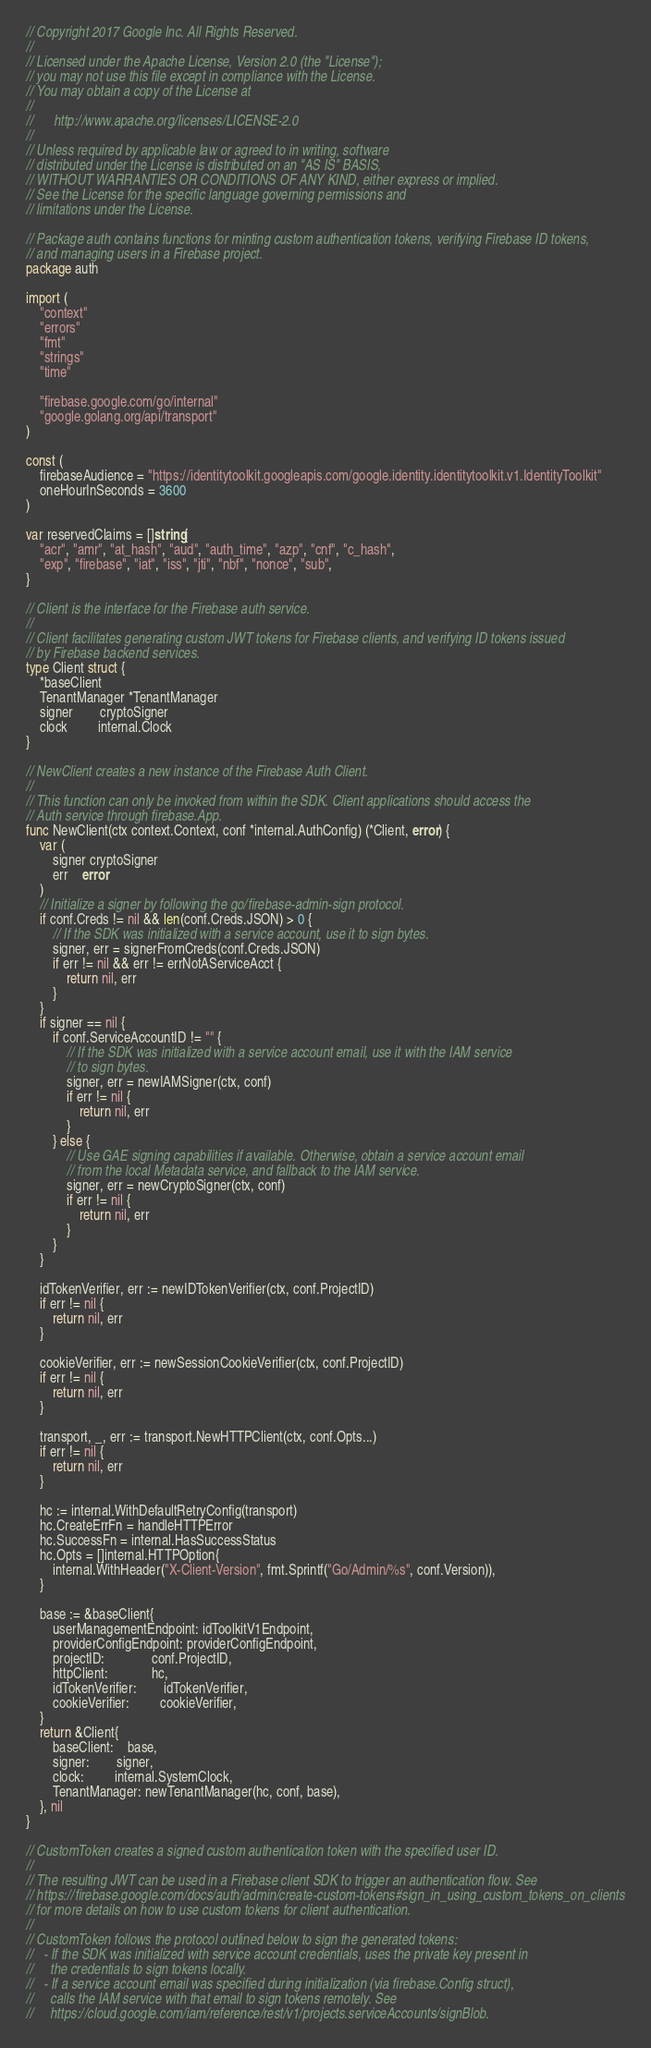<code> <loc_0><loc_0><loc_500><loc_500><_Go_>// Copyright 2017 Google Inc. All Rights Reserved.
//
// Licensed under the Apache License, Version 2.0 (the "License");
// you may not use this file except in compliance with the License.
// You may obtain a copy of the License at
//
//      http://www.apache.org/licenses/LICENSE-2.0
//
// Unless required by applicable law or agreed to in writing, software
// distributed under the License is distributed on an "AS IS" BASIS,
// WITHOUT WARRANTIES OR CONDITIONS OF ANY KIND, either express or implied.
// See the License for the specific language governing permissions and
// limitations under the License.

// Package auth contains functions for minting custom authentication tokens, verifying Firebase ID tokens,
// and managing users in a Firebase project.
package auth

import (
	"context"
	"errors"
	"fmt"
	"strings"
	"time"

	"firebase.google.com/go/internal"
	"google.golang.org/api/transport"
)

const (
	firebaseAudience = "https://identitytoolkit.googleapis.com/google.identity.identitytoolkit.v1.IdentityToolkit"
	oneHourInSeconds = 3600
)

var reservedClaims = []string{
	"acr", "amr", "at_hash", "aud", "auth_time", "azp", "cnf", "c_hash",
	"exp", "firebase", "iat", "iss", "jti", "nbf", "nonce", "sub",
}

// Client is the interface for the Firebase auth service.
//
// Client facilitates generating custom JWT tokens for Firebase clients, and verifying ID tokens issued
// by Firebase backend services.
type Client struct {
	*baseClient
	TenantManager *TenantManager
	signer        cryptoSigner
	clock         internal.Clock
}

// NewClient creates a new instance of the Firebase Auth Client.
//
// This function can only be invoked from within the SDK. Client applications should access the
// Auth service through firebase.App.
func NewClient(ctx context.Context, conf *internal.AuthConfig) (*Client, error) {
	var (
		signer cryptoSigner
		err    error
	)
	// Initialize a signer by following the go/firebase-admin-sign protocol.
	if conf.Creds != nil && len(conf.Creds.JSON) > 0 {
		// If the SDK was initialized with a service account, use it to sign bytes.
		signer, err = signerFromCreds(conf.Creds.JSON)
		if err != nil && err != errNotAServiceAcct {
			return nil, err
		}
	}
	if signer == nil {
		if conf.ServiceAccountID != "" {
			// If the SDK was initialized with a service account email, use it with the IAM service
			// to sign bytes.
			signer, err = newIAMSigner(ctx, conf)
			if err != nil {
				return nil, err
			}
		} else {
			// Use GAE signing capabilities if available. Otherwise, obtain a service account email
			// from the local Metadata service, and fallback to the IAM service.
			signer, err = newCryptoSigner(ctx, conf)
			if err != nil {
				return nil, err
			}
		}
	}

	idTokenVerifier, err := newIDTokenVerifier(ctx, conf.ProjectID)
	if err != nil {
		return nil, err
	}

	cookieVerifier, err := newSessionCookieVerifier(ctx, conf.ProjectID)
	if err != nil {
		return nil, err
	}

	transport, _, err := transport.NewHTTPClient(ctx, conf.Opts...)
	if err != nil {
		return nil, err
	}

	hc := internal.WithDefaultRetryConfig(transport)
	hc.CreateErrFn = handleHTTPError
	hc.SuccessFn = internal.HasSuccessStatus
	hc.Opts = []internal.HTTPOption{
		internal.WithHeader("X-Client-Version", fmt.Sprintf("Go/Admin/%s", conf.Version)),
	}

	base := &baseClient{
		userManagementEndpoint: idToolkitV1Endpoint,
		providerConfigEndpoint: providerConfigEndpoint,
		projectID:              conf.ProjectID,
		httpClient:             hc,
		idTokenVerifier:        idTokenVerifier,
		cookieVerifier:         cookieVerifier,
	}
	return &Client{
		baseClient:    base,
		signer:        signer,
		clock:         internal.SystemClock,
		TenantManager: newTenantManager(hc, conf, base),
	}, nil
}

// CustomToken creates a signed custom authentication token with the specified user ID.
//
// The resulting JWT can be used in a Firebase client SDK to trigger an authentication flow. See
// https://firebase.google.com/docs/auth/admin/create-custom-tokens#sign_in_using_custom_tokens_on_clients
// for more details on how to use custom tokens for client authentication.
//
// CustomToken follows the protocol outlined below to sign the generated tokens:
//   - If the SDK was initialized with service account credentials, uses the private key present in
//     the credentials to sign tokens locally.
//   - If a service account email was specified during initialization (via firebase.Config struct),
//     calls the IAM service with that email to sign tokens remotely. See
//     https://cloud.google.com/iam/reference/rest/v1/projects.serviceAccounts/signBlob.</code> 